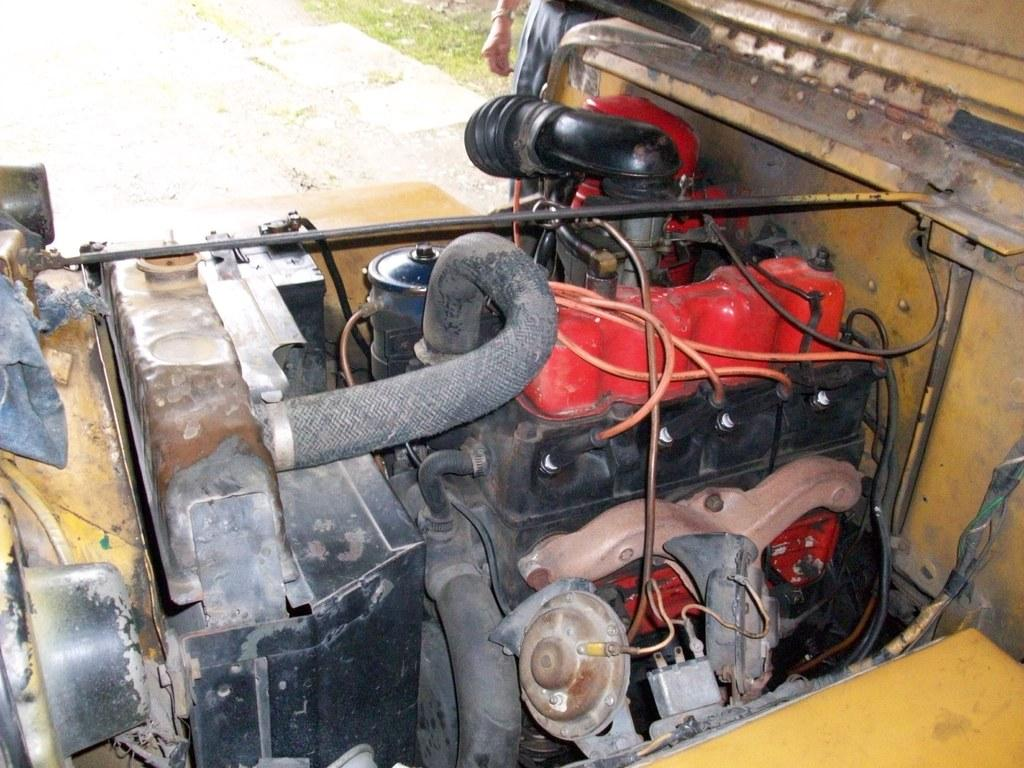What is the main subject of the image? The main subject of the image is an engine part of a vehicle. Can you describe any other elements in the image? Yes, there is a person and grass visible in the image. What type of tooth can be seen in the image? There is no tooth present in the image. What shape is the cover on the engine part in the image? There is no cover on the engine part in the image, and therefore no shape can be determined. 